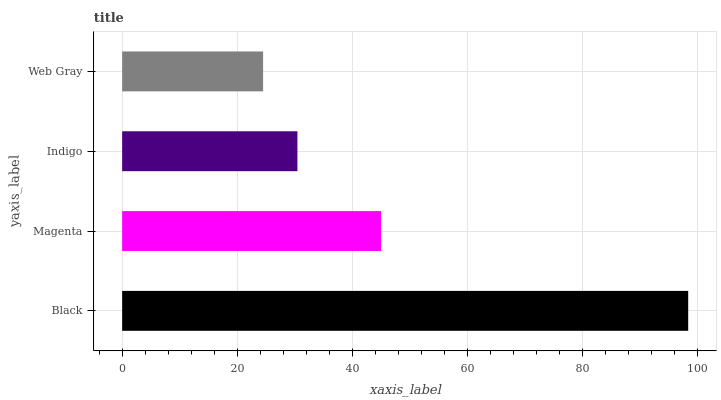Is Web Gray the minimum?
Answer yes or no. Yes. Is Black the maximum?
Answer yes or no. Yes. Is Magenta the minimum?
Answer yes or no. No. Is Magenta the maximum?
Answer yes or no. No. Is Black greater than Magenta?
Answer yes or no. Yes. Is Magenta less than Black?
Answer yes or no. Yes. Is Magenta greater than Black?
Answer yes or no. No. Is Black less than Magenta?
Answer yes or no. No. Is Magenta the high median?
Answer yes or no. Yes. Is Indigo the low median?
Answer yes or no. Yes. Is Black the high median?
Answer yes or no. No. Is Magenta the low median?
Answer yes or no. No. 